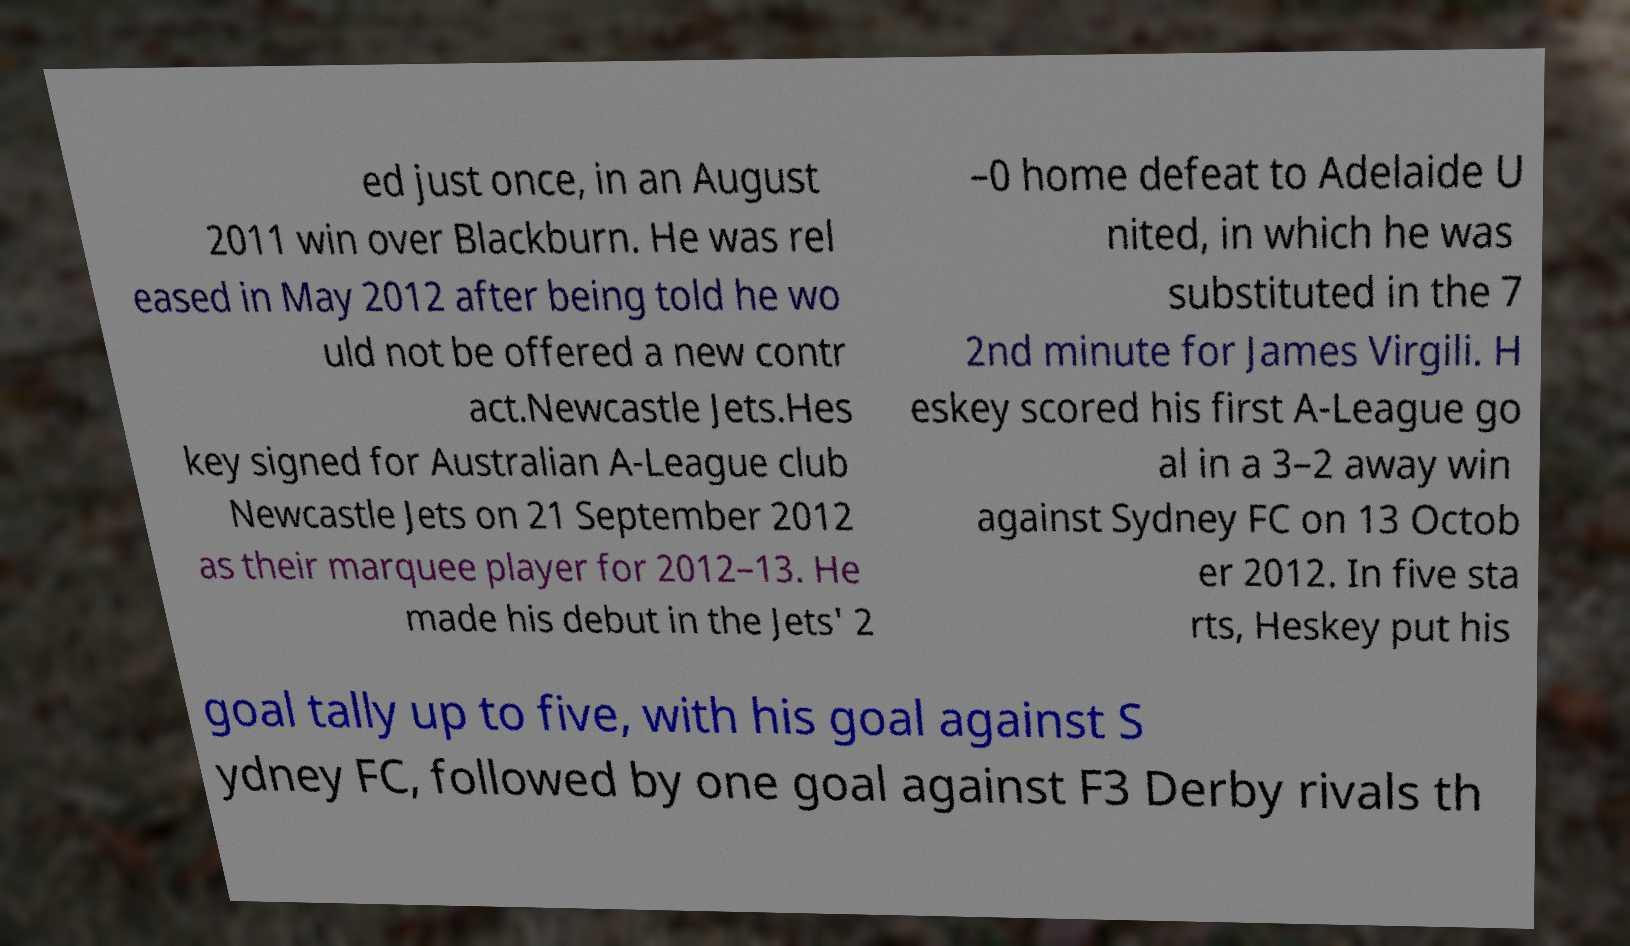For documentation purposes, I need the text within this image transcribed. Could you provide that? ed just once, in an August 2011 win over Blackburn. He was rel eased in May 2012 after being told he wo uld not be offered a new contr act.Newcastle Jets.Hes key signed for Australian A-League club Newcastle Jets on 21 September 2012 as their marquee player for 2012–13. He made his debut in the Jets' 2 –0 home defeat to Adelaide U nited, in which he was substituted in the 7 2nd minute for James Virgili. H eskey scored his first A-League go al in a 3–2 away win against Sydney FC on 13 Octob er 2012. In five sta rts, Heskey put his goal tally up to five, with his goal against S ydney FC, followed by one goal against F3 Derby rivals th 